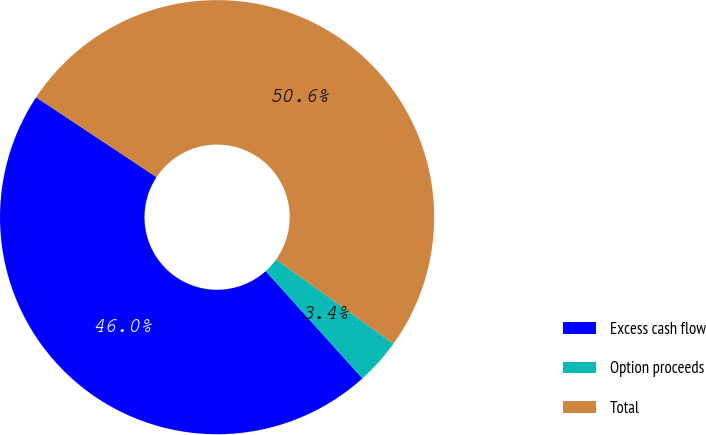Convert chart. <chart><loc_0><loc_0><loc_500><loc_500><pie_chart><fcel>Excess cash flow<fcel>Option proceeds<fcel>Total<nl><fcel>45.99%<fcel>3.42%<fcel>50.59%<nl></chart> 